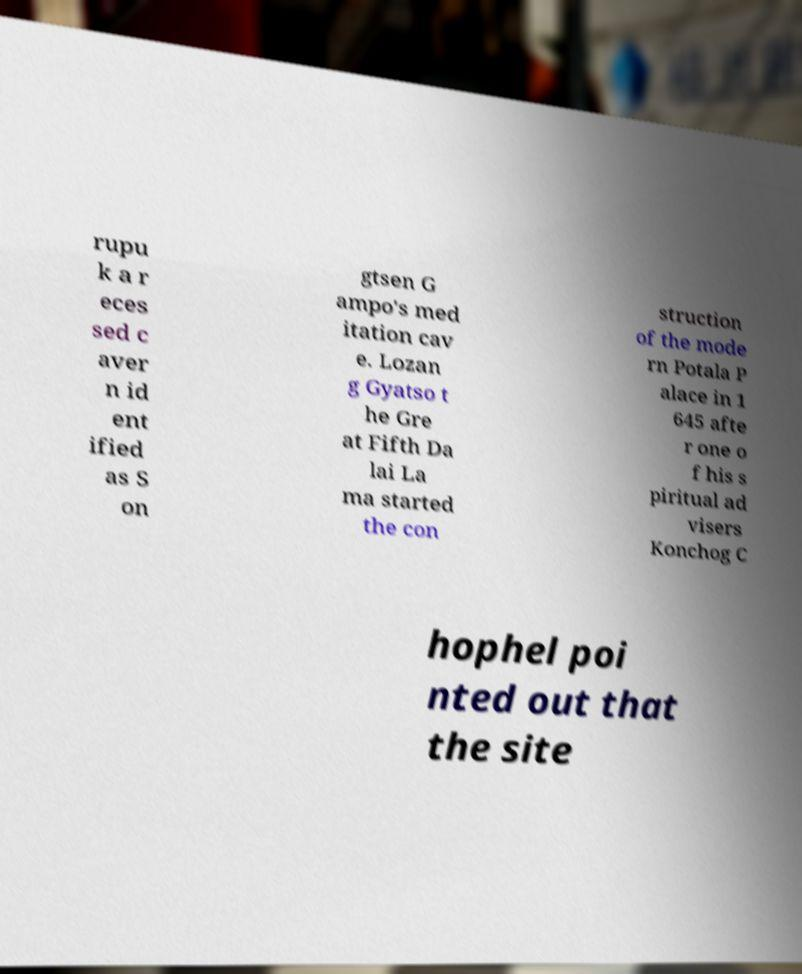There's text embedded in this image that I need extracted. Can you transcribe it verbatim? rupu k a r eces sed c aver n id ent ified as S on gtsen G ampo's med itation cav e. Lozan g Gyatso t he Gre at Fifth Da lai La ma started the con struction of the mode rn Potala P alace in 1 645 afte r one o f his s piritual ad visers Konchog C hophel poi nted out that the site 